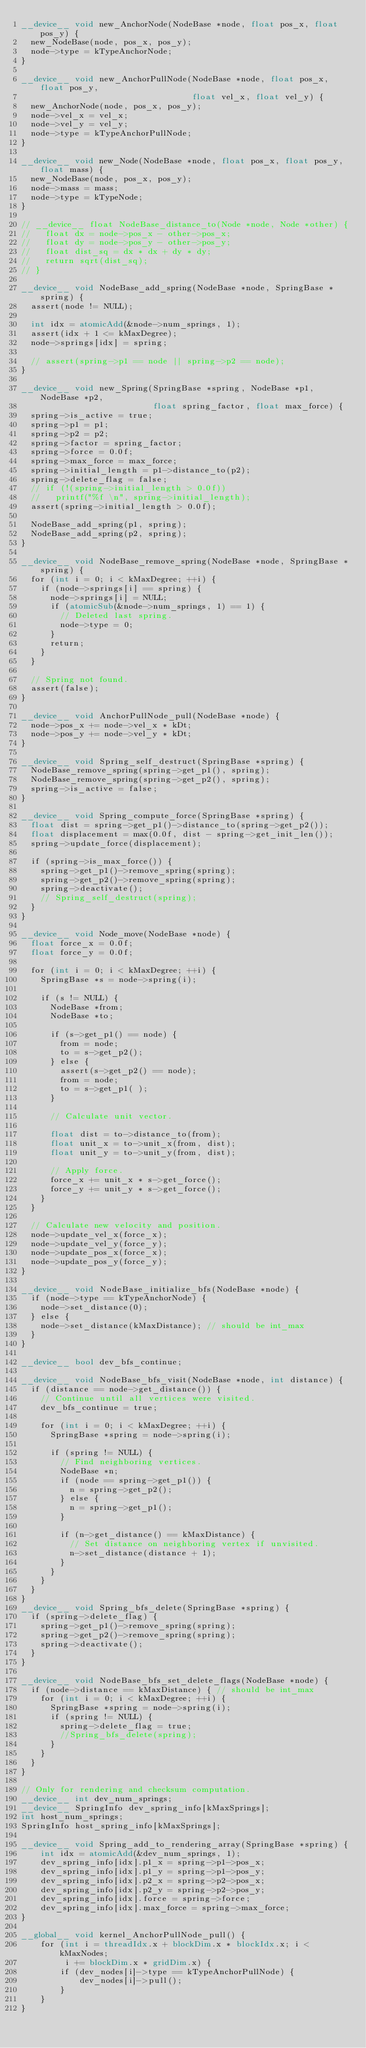Convert code to text. <code><loc_0><loc_0><loc_500><loc_500><_Cuda_>__device__ void new_AnchorNode(NodeBase *node, float pos_x, float pos_y) {
  new_NodeBase(node, pos_x, pos_y);
  node->type = kTypeAnchorNode;
}

__device__ void new_AnchorPullNode(NodeBase *node, float pos_x, float pos_y,
                                   float vel_x, float vel_y) {
  new_AnchorNode(node, pos_x, pos_y);
  node->vel_x = vel_x;
  node->vel_y = vel_y;
  node->type = kTypeAnchorPullNode;
}

__device__ void new_Node(NodeBase *node, float pos_x, float pos_y, float mass) {
  new_NodeBase(node, pos_x, pos_y);
  node->mass = mass;
  node->type = kTypeNode;
}

// __device__ float NodeBase_distance_to(Node *node, Node *other) {
//   float dx = node->pos_x - other->pos_x;
//   float dy = node->pos_y - other->pos_y;
//   float dist_sq = dx * dx + dy * dy;
//   return sqrt(dist_sq);
// }

__device__ void NodeBase_add_spring(NodeBase *node, SpringBase *spring) {
  assert(node != NULL);

  int idx = atomicAdd(&node->num_springs, 1);
  assert(idx + 1 <= kMaxDegree);
  node->springs[idx] = spring;

  // assert(spring->p1 == node || spring->p2 == node);
}

__device__ void new_Spring(SpringBase *spring, NodeBase *p1, NodeBase *p2,
                           float spring_factor, float max_force) {
  spring->is_active = true;
  spring->p1 = p1;
  spring->p2 = p2;
  spring->factor = spring_factor;
  spring->force = 0.0f;
  spring->max_force = max_force;
  spring->initial_length = p1->distance_to(p2);
  spring->delete_flag = false;
  // if (!(spring->initial_length > 0.0f))
  //   printf("%f \n", spring->initial_length);
  assert(spring->initial_length > 0.0f);

  NodeBase_add_spring(p1, spring);
  NodeBase_add_spring(p2, spring);
}

__device__ void NodeBase_remove_spring(NodeBase *node, SpringBase *spring) {
  for (int i = 0; i < kMaxDegree; ++i) {
    if (node->springs[i] == spring) {
      node->springs[i] = NULL;
      if (atomicSub(&node->num_springs, 1) == 1) {
        // Deleted last spring.
        node->type = 0;
      }
      return;
    }
  }

  // Spring not found.
  assert(false);
}

__device__ void AnchorPullNode_pull(NodeBase *node) {
  node->pos_x += node->vel_x * kDt;
  node->pos_y += node->vel_y * kDt;
}

__device__ void Spring_self_destruct(SpringBase *spring) {
  NodeBase_remove_spring(spring->get_p1(), spring);
  NodeBase_remove_spring(spring->get_p2(), spring);
  spring->is_active = false;
}

__device__ void Spring_compute_force(SpringBase *spring) {
  float dist = spring->get_p1()->distance_to(spring->get_p2());
  float displacement = max(0.0f, dist - spring->get_init_len());
  spring->update_force(displacement);

  if (spring->is_max_force()) {
    spring->get_p1()->remove_spring(spring);
    spring->get_p2()->remove_spring(spring);
    spring->deactivate();
    // Spring_self_destruct(spring);
  }
}

__device__ void Node_move(NodeBase *node) {
  float force_x = 0.0f;
  float force_y = 0.0f;

  for (int i = 0; i < kMaxDegree; ++i) {
    SpringBase *s = node->spring(i);

    if (s != NULL) {
      NodeBase *from;
      NodeBase *to;

      if (s->get_p1() == node) {
        from = node;
        to = s->get_p2();
      } else {
        assert(s->get_p2() == node);
        from = node;
        to = s->get_p1( );
      }

      // Calculate unit vector.

      float dist = to->distance_to(from);
      float unit_x = to->unit_x(from, dist);
      float unit_y = to->unit_y(from, dist);

      // Apply force.
      force_x += unit_x * s->get_force();
      force_y += unit_y * s->get_force();
    }
  }

  // Calculate new velocity and position.
  node->update_vel_x(force_x);
  node->update_vel_y(force_y);
  node->update_pos_x(force_x);
  node->update_pos_y(force_y);
}

__device__ void NodeBase_initialize_bfs(NodeBase *node) {
  if (node->type == kTypeAnchorNode) {
    node->set_distance(0);
  } else {
    node->set_distance(kMaxDistance); // should be int_max
  }
}

__device__ bool dev_bfs_continue;

__device__ void NodeBase_bfs_visit(NodeBase *node, int distance) {
  if (distance == node->get_distance()) {
    // Continue until all vertices were visited.
    dev_bfs_continue = true;

    for (int i = 0; i < kMaxDegree; ++i) {
      SpringBase *spring = node->spring(i);

      if (spring != NULL) {
        // Find neighboring vertices.
        NodeBase *n;
        if (node == spring->get_p1()) {
          n = spring->get_p2();
        } else {
          n = spring->get_p1();
        }

        if (n->get_distance() == kMaxDistance) {
          // Set distance on neighboring vertex if unvisited.
          n->set_distance(distance + 1);
        }
      }
    }
  }
}
__device__ void Spring_bfs_delete(SpringBase *spring) {
  if (spring->delete_flag) {
    spring->get_p1()->remove_spring(spring);
    spring->get_p2()->remove_spring(spring);
    spring->deactivate();
  }
}

__device__ void NodeBase_bfs_set_delete_flags(NodeBase *node) {
  if (node->distance == kMaxDistance) { // should be int_max
    for (int i = 0; i < kMaxDegree; ++i) {
      SpringBase *spring = node->spring(i);
      if (spring != NULL) {
        spring->delete_flag = true;
        //Spring_bfs_delete(spring);
      }
    }
  }
}

// Only for rendering and checksum computation.
__device__ int dev_num_springs;
__device__ SpringInfo dev_spring_info[kMaxSprings];
int host_num_springs;
SpringInfo host_spring_info[kMaxSprings];

__device__ void Spring_add_to_rendering_array(SpringBase *spring) {
    int idx = atomicAdd(&dev_num_springs, 1);
    dev_spring_info[idx].p1_x = spring->p1->pos_x;
    dev_spring_info[idx].p1_y = spring->p1->pos_y;
    dev_spring_info[idx].p2_x = spring->p2->pos_x;
    dev_spring_info[idx].p2_y = spring->p2->pos_y;
    dev_spring_info[idx].force = spring->force;
    dev_spring_info[idx].max_force = spring->max_force;
}

__global__ void kernel_AnchorPullNode_pull() {
    for (int i = threadIdx.x + blockDim.x * blockIdx.x; i < kMaxNodes;
         i += blockDim.x * gridDim.x) {
        if (dev_nodes[i]->type == kTypeAnchorPullNode) {
            dev_nodes[i]->pull();
        }
    }
}
</code> 